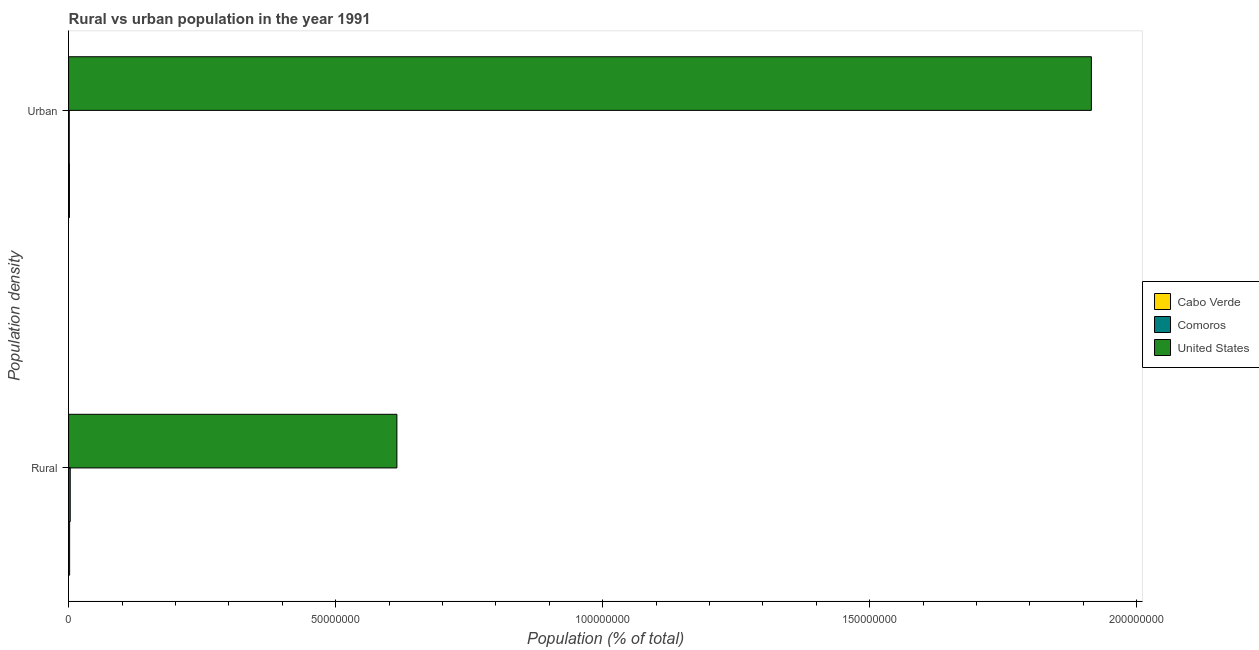How many different coloured bars are there?
Your answer should be very brief. 3. How many bars are there on the 2nd tick from the top?
Offer a very short reply. 3. How many bars are there on the 1st tick from the bottom?
Ensure brevity in your answer.  3. What is the label of the 2nd group of bars from the top?
Ensure brevity in your answer.  Rural. What is the rural population density in Cabo Verde?
Offer a terse response. 1.92e+05. Across all countries, what is the maximum rural population density?
Keep it short and to the point. 6.15e+07. Across all countries, what is the minimum urban population density?
Keep it short and to the point. 1.21e+05. In which country was the urban population density maximum?
Provide a succinct answer. United States. In which country was the rural population density minimum?
Give a very brief answer. Cabo Verde. What is the total rural population density in the graph?
Offer a terse response. 6.20e+07. What is the difference between the rural population density in United States and that in Cabo Verde?
Your response must be concise. 6.13e+07. What is the difference between the rural population density in Comoros and the urban population density in Cabo Verde?
Provide a short and direct response. 1.49e+05. What is the average urban population density per country?
Ensure brevity in your answer.  6.39e+07. What is the difference between the rural population density and urban population density in United States?
Offer a very short reply. -1.30e+08. What is the ratio of the rural population density in United States to that in Cabo Verde?
Offer a very short reply. 320.21. Is the rural population density in United States less than that in Cabo Verde?
Give a very brief answer. No. What does the 3rd bar from the top in Urban represents?
Offer a terse response. Cabo Verde. How many countries are there in the graph?
Make the answer very short. 3. Does the graph contain grids?
Your answer should be compact. No. Where does the legend appear in the graph?
Your answer should be very brief. Center right. How are the legend labels stacked?
Offer a terse response. Vertical. What is the title of the graph?
Provide a succinct answer. Rural vs urban population in the year 1991. What is the label or title of the X-axis?
Provide a succinct answer. Population (% of total). What is the label or title of the Y-axis?
Ensure brevity in your answer.  Population density. What is the Population (% of total) of Cabo Verde in Rural?
Offer a terse response. 1.92e+05. What is the Population (% of total) of Comoros in Rural?
Your response must be concise. 3.06e+05. What is the Population (% of total) of United States in Rural?
Your response must be concise. 6.15e+07. What is the Population (% of total) of Cabo Verde in Urban?
Offer a very short reply. 1.57e+05. What is the Population (% of total) in Comoros in Urban?
Give a very brief answer. 1.21e+05. What is the Population (% of total) of United States in Urban?
Offer a terse response. 1.92e+08. Across all Population density, what is the maximum Population (% of total) in Cabo Verde?
Provide a succinct answer. 1.92e+05. Across all Population density, what is the maximum Population (% of total) of Comoros?
Make the answer very short. 3.06e+05. Across all Population density, what is the maximum Population (% of total) of United States?
Provide a short and direct response. 1.92e+08. Across all Population density, what is the minimum Population (% of total) of Cabo Verde?
Ensure brevity in your answer.  1.57e+05. Across all Population density, what is the minimum Population (% of total) of Comoros?
Offer a terse response. 1.21e+05. Across all Population density, what is the minimum Population (% of total) of United States?
Keep it short and to the point. 6.15e+07. What is the total Population (% of total) in Cabo Verde in the graph?
Keep it short and to the point. 3.49e+05. What is the total Population (% of total) of Comoros in the graph?
Provide a succinct answer. 4.28e+05. What is the total Population (% of total) in United States in the graph?
Keep it short and to the point. 2.53e+08. What is the difference between the Population (% of total) in Cabo Verde in Rural and that in Urban?
Make the answer very short. 3.46e+04. What is the difference between the Population (% of total) in Comoros in Rural and that in Urban?
Offer a very short reply. 1.85e+05. What is the difference between the Population (% of total) of United States in Rural and that in Urban?
Provide a short and direct response. -1.30e+08. What is the difference between the Population (% of total) of Cabo Verde in Rural and the Population (% of total) of Comoros in Urban?
Keep it short and to the point. 7.07e+04. What is the difference between the Population (% of total) of Cabo Verde in Rural and the Population (% of total) of United States in Urban?
Offer a very short reply. -1.91e+08. What is the difference between the Population (% of total) of Comoros in Rural and the Population (% of total) of United States in Urban?
Your answer should be very brief. -1.91e+08. What is the average Population (% of total) of Cabo Verde per Population density?
Keep it short and to the point. 1.75e+05. What is the average Population (% of total) in Comoros per Population density?
Your answer should be very brief. 2.14e+05. What is the average Population (% of total) in United States per Population density?
Offer a very short reply. 1.26e+08. What is the difference between the Population (% of total) of Cabo Verde and Population (% of total) of Comoros in Rural?
Your answer should be very brief. -1.14e+05. What is the difference between the Population (% of total) of Cabo Verde and Population (% of total) of United States in Rural?
Offer a very short reply. -6.13e+07. What is the difference between the Population (% of total) of Comoros and Population (% of total) of United States in Rural?
Ensure brevity in your answer.  -6.12e+07. What is the difference between the Population (% of total) in Cabo Verde and Population (% of total) in Comoros in Urban?
Make the answer very short. 3.61e+04. What is the difference between the Population (% of total) of Cabo Verde and Population (% of total) of United States in Urban?
Ensure brevity in your answer.  -1.91e+08. What is the difference between the Population (% of total) of Comoros and Population (% of total) of United States in Urban?
Offer a very short reply. -1.91e+08. What is the ratio of the Population (% of total) of Cabo Verde in Rural to that in Urban?
Your answer should be very brief. 1.22. What is the ratio of the Population (% of total) of Comoros in Rural to that in Urban?
Give a very brief answer. 2.53. What is the ratio of the Population (% of total) in United States in Rural to that in Urban?
Your answer should be compact. 0.32. What is the difference between the highest and the second highest Population (% of total) in Cabo Verde?
Offer a terse response. 3.46e+04. What is the difference between the highest and the second highest Population (% of total) in Comoros?
Your response must be concise. 1.85e+05. What is the difference between the highest and the second highest Population (% of total) in United States?
Give a very brief answer. 1.30e+08. What is the difference between the highest and the lowest Population (% of total) in Cabo Verde?
Your response must be concise. 3.46e+04. What is the difference between the highest and the lowest Population (% of total) of Comoros?
Make the answer very short. 1.85e+05. What is the difference between the highest and the lowest Population (% of total) in United States?
Ensure brevity in your answer.  1.30e+08. 